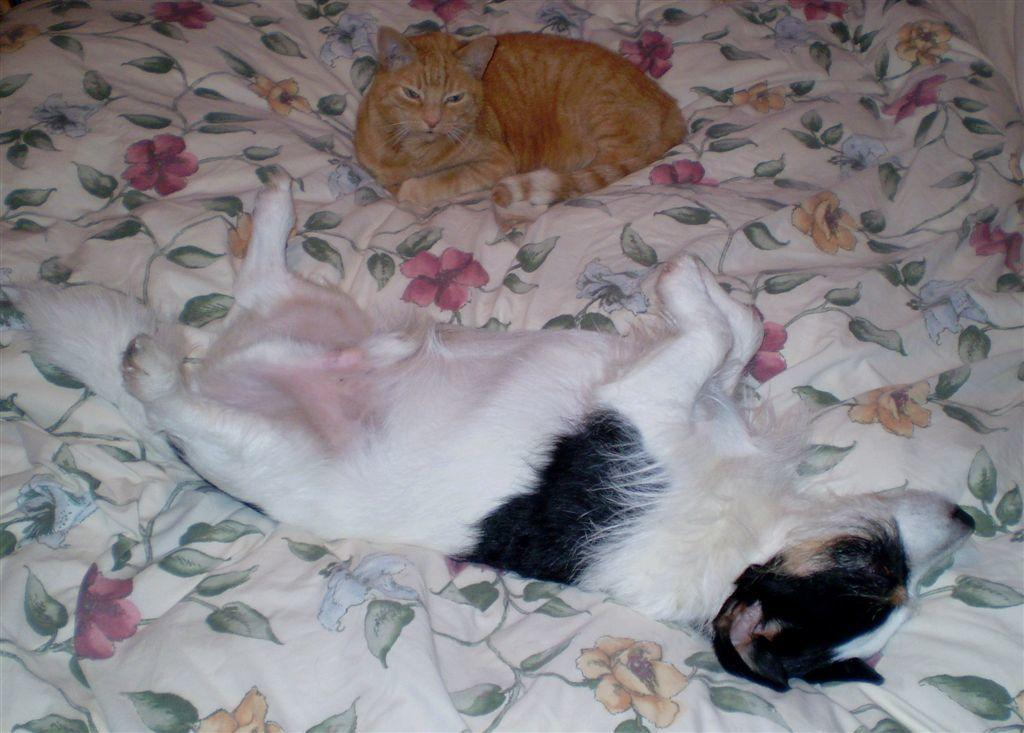What type of animals are in the image? There are cats in the image. Where are the cats located in the image? The cats are on a bed. What type of arm is visible in the image? There is no arm visible in the image; it only features cats on a bed. 